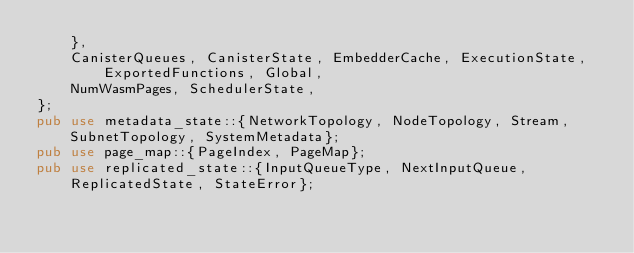Convert code to text. <code><loc_0><loc_0><loc_500><loc_500><_Rust_>    },
    CanisterQueues, CanisterState, EmbedderCache, ExecutionState, ExportedFunctions, Global,
    NumWasmPages, SchedulerState,
};
pub use metadata_state::{NetworkTopology, NodeTopology, Stream, SubnetTopology, SystemMetadata};
pub use page_map::{PageIndex, PageMap};
pub use replicated_state::{InputQueueType, NextInputQueue, ReplicatedState, StateError};
</code> 